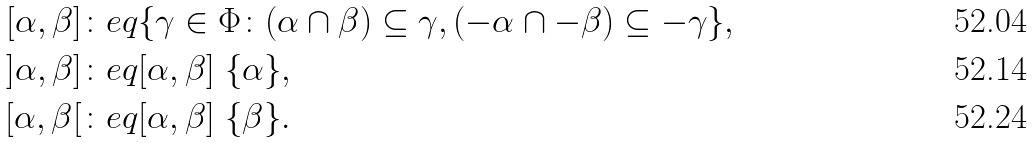Convert formula to latex. <formula><loc_0><loc_0><loc_500><loc_500>[ \alpha , \beta ] & \colon e q \{ \gamma \in \Phi \colon ( \alpha \cap \beta ) \subseteq \gamma , ( - \alpha \cap - \beta ) \subseteq - \gamma \} , \\ ] \alpha , \beta ] & \colon e q [ \alpha , \beta ] \ \{ \alpha \} , \\ [ \alpha , \beta [ & \colon e q [ \alpha , \beta ] \ \{ \beta \} .</formula> 